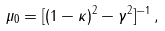Convert formula to latex. <formula><loc_0><loc_0><loc_500><loc_500>\mu _ { 0 } = [ ( 1 - \kappa ) ^ { 2 } - \gamma ^ { 2 } ] ^ { - 1 } \, ,</formula> 